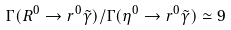<formula> <loc_0><loc_0><loc_500><loc_500>\Gamma ( R ^ { 0 } \to r ^ { 0 } \tilde { \gamma } ) / \Gamma ( \eta ^ { 0 } \to r ^ { 0 } \tilde { \gamma } ) \simeq 9</formula> 